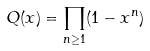Convert formula to latex. <formula><loc_0><loc_0><loc_500><loc_500>Q ( x ) = \prod _ { n \geq 1 } ( 1 - x ^ { n } )</formula> 